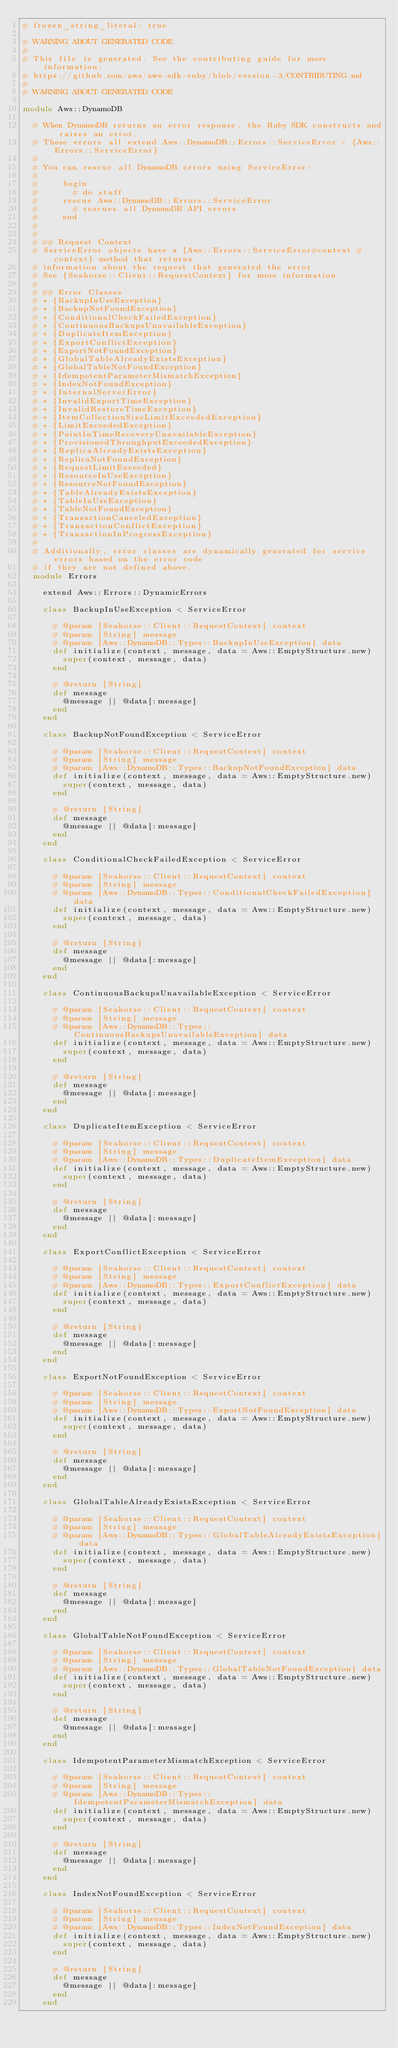<code> <loc_0><loc_0><loc_500><loc_500><_Ruby_># frozen_string_literal: true

# WARNING ABOUT GENERATED CODE
#
# This file is generated. See the contributing guide for more information:
# https://github.com/aws/aws-sdk-ruby/blob/version-3/CONTRIBUTING.md
#
# WARNING ABOUT GENERATED CODE

module Aws::DynamoDB

  # When DynamoDB returns an error response, the Ruby SDK constructs and raises an error.
  # These errors all extend Aws::DynamoDB::Errors::ServiceError < {Aws::Errors::ServiceError}
  #
  # You can rescue all DynamoDB errors using ServiceError:
  #
  #     begin
  #       # do stuff
  #     rescue Aws::DynamoDB::Errors::ServiceError
  #       # rescues all DynamoDB API errors
  #     end
  #
  #
  # ## Request Context
  # ServiceError objects have a {Aws::Errors::ServiceError#context #context} method that returns
  # information about the request that generated the error.
  # See {Seahorse::Client::RequestContext} for more information.
  #
  # ## Error Classes
  # * {BackupInUseException}
  # * {BackupNotFoundException}
  # * {ConditionalCheckFailedException}
  # * {ContinuousBackupsUnavailableException}
  # * {DuplicateItemException}
  # * {ExportConflictException}
  # * {ExportNotFoundException}
  # * {GlobalTableAlreadyExistsException}
  # * {GlobalTableNotFoundException}
  # * {IdempotentParameterMismatchException}
  # * {IndexNotFoundException}
  # * {InternalServerError}
  # * {InvalidExportTimeException}
  # * {InvalidRestoreTimeException}
  # * {ItemCollectionSizeLimitExceededException}
  # * {LimitExceededException}
  # * {PointInTimeRecoveryUnavailableException}
  # * {ProvisionedThroughputExceededException}
  # * {ReplicaAlreadyExistsException}
  # * {ReplicaNotFoundException}
  # * {RequestLimitExceeded}
  # * {ResourceInUseException}
  # * {ResourceNotFoundException}
  # * {TableAlreadyExistsException}
  # * {TableInUseException}
  # * {TableNotFoundException}
  # * {TransactionCanceledException}
  # * {TransactionConflictException}
  # * {TransactionInProgressException}
  #
  # Additionally, error classes are dynamically generated for service errors based on the error code
  # if they are not defined above.
  module Errors

    extend Aws::Errors::DynamicErrors

    class BackupInUseException < ServiceError

      # @param [Seahorse::Client::RequestContext] context
      # @param [String] message
      # @param [Aws::DynamoDB::Types::BackupInUseException] data
      def initialize(context, message, data = Aws::EmptyStructure.new)
        super(context, message, data)
      end

      # @return [String]
      def message
        @message || @data[:message]
      end
    end

    class BackupNotFoundException < ServiceError

      # @param [Seahorse::Client::RequestContext] context
      # @param [String] message
      # @param [Aws::DynamoDB::Types::BackupNotFoundException] data
      def initialize(context, message, data = Aws::EmptyStructure.new)
        super(context, message, data)
      end

      # @return [String]
      def message
        @message || @data[:message]
      end
    end

    class ConditionalCheckFailedException < ServiceError

      # @param [Seahorse::Client::RequestContext] context
      # @param [String] message
      # @param [Aws::DynamoDB::Types::ConditionalCheckFailedException] data
      def initialize(context, message, data = Aws::EmptyStructure.new)
        super(context, message, data)
      end

      # @return [String]
      def message
        @message || @data[:message]
      end
    end

    class ContinuousBackupsUnavailableException < ServiceError

      # @param [Seahorse::Client::RequestContext] context
      # @param [String] message
      # @param [Aws::DynamoDB::Types::ContinuousBackupsUnavailableException] data
      def initialize(context, message, data = Aws::EmptyStructure.new)
        super(context, message, data)
      end

      # @return [String]
      def message
        @message || @data[:message]
      end
    end

    class DuplicateItemException < ServiceError

      # @param [Seahorse::Client::RequestContext] context
      # @param [String] message
      # @param [Aws::DynamoDB::Types::DuplicateItemException] data
      def initialize(context, message, data = Aws::EmptyStructure.new)
        super(context, message, data)
      end

      # @return [String]
      def message
        @message || @data[:message]
      end
    end

    class ExportConflictException < ServiceError

      # @param [Seahorse::Client::RequestContext] context
      # @param [String] message
      # @param [Aws::DynamoDB::Types::ExportConflictException] data
      def initialize(context, message, data = Aws::EmptyStructure.new)
        super(context, message, data)
      end

      # @return [String]
      def message
        @message || @data[:message]
      end
    end

    class ExportNotFoundException < ServiceError

      # @param [Seahorse::Client::RequestContext] context
      # @param [String] message
      # @param [Aws::DynamoDB::Types::ExportNotFoundException] data
      def initialize(context, message, data = Aws::EmptyStructure.new)
        super(context, message, data)
      end

      # @return [String]
      def message
        @message || @data[:message]
      end
    end

    class GlobalTableAlreadyExistsException < ServiceError

      # @param [Seahorse::Client::RequestContext] context
      # @param [String] message
      # @param [Aws::DynamoDB::Types::GlobalTableAlreadyExistsException] data
      def initialize(context, message, data = Aws::EmptyStructure.new)
        super(context, message, data)
      end

      # @return [String]
      def message
        @message || @data[:message]
      end
    end

    class GlobalTableNotFoundException < ServiceError

      # @param [Seahorse::Client::RequestContext] context
      # @param [String] message
      # @param [Aws::DynamoDB::Types::GlobalTableNotFoundException] data
      def initialize(context, message, data = Aws::EmptyStructure.new)
        super(context, message, data)
      end

      # @return [String]
      def message
        @message || @data[:message]
      end
    end

    class IdempotentParameterMismatchException < ServiceError

      # @param [Seahorse::Client::RequestContext] context
      # @param [String] message
      # @param [Aws::DynamoDB::Types::IdempotentParameterMismatchException] data
      def initialize(context, message, data = Aws::EmptyStructure.new)
        super(context, message, data)
      end

      # @return [String]
      def message
        @message || @data[:message]
      end
    end

    class IndexNotFoundException < ServiceError

      # @param [Seahorse::Client::RequestContext] context
      # @param [String] message
      # @param [Aws::DynamoDB::Types::IndexNotFoundException] data
      def initialize(context, message, data = Aws::EmptyStructure.new)
        super(context, message, data)
      end

      # @return [String]
      def message
        @message || @data[:message]
      end
    end
</code> 